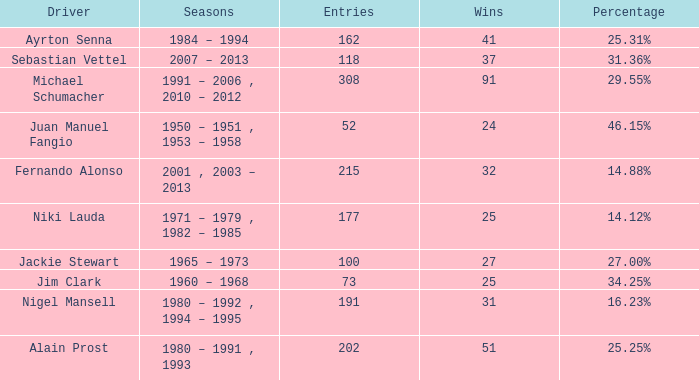Which driver has less than 37 wins and at 14.12%? 177.0. 